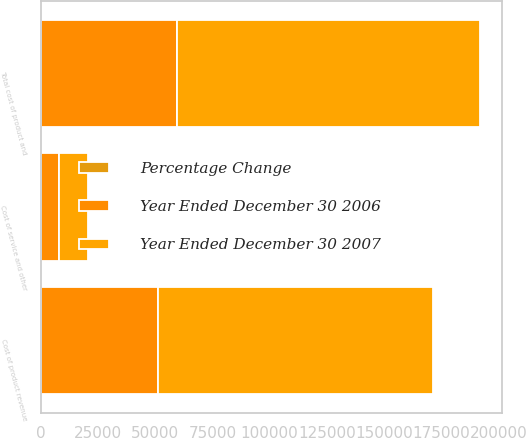Convert chart. <chart><loc_0><loc_0><loc_500><loc_500><stacked_bar_chart><ecel><fcel>Cost of product revenue<fcel>Cost of service and other<fcel>Total cost of product and<nl><fcel>Year Ended December 30 2007<fcel>119991<fcel>12445<fcel>132436<nl><fcel>Year Ended December 30 2006<fcel>51271<fcel>8073<fcel>59344<nl><fcel>Percentage Change<fcel>134<fcel>54<fcel>123<nl></chart> 